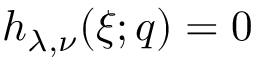<formula> <loc_0><loc_0><loc_500><loc_500>h _ { \lambda , \nu } ( \xi ; q ) = 0</formula> 